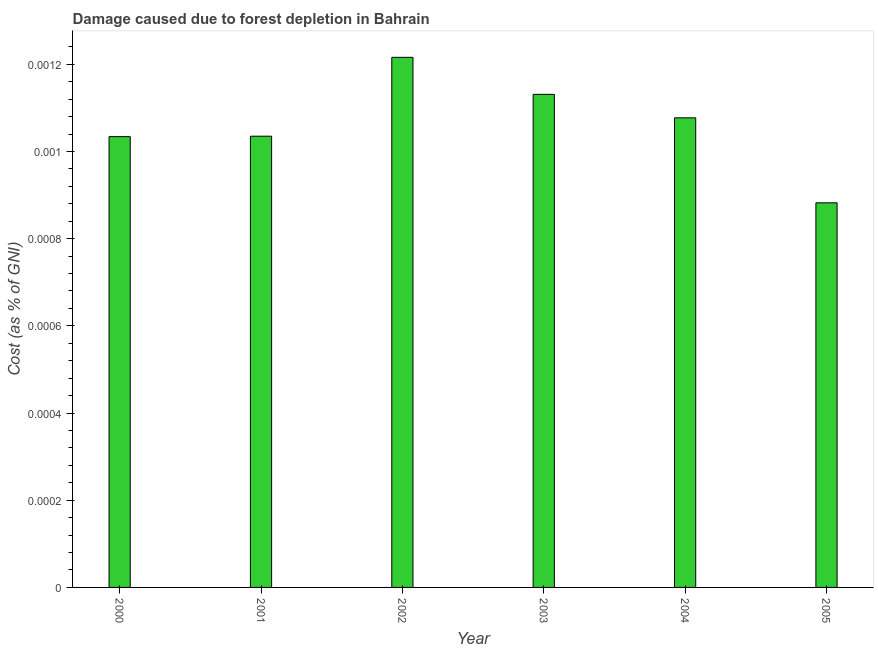Does the graph contain grids?
Your answer should be very brief. No. What is the title of the graph?
Offer a very short reply. Damage caused due to forest depletion in Bahrain. What is the label or title of the Y-axis?
Make the answer very short. Cost (as % of GNI). What is the damage caused due to forest depletion in 2004?
Your response must be concise. 0. Across all years, what is the maximum damage caused due to forest depletion?
Ensure brevity in your answer.  0. Across all years, what is the minimum damage caused due to forest depletion?
Give a very brief answer. 0. In which year was the damage caused due to forest depletion maximum?
Keep it short and to the point. 2002. In which year was the damage caused due to forest depletion minimum?
Keep it short and to the point. 2005. What is the sum of the damage caused due to forest depletion?
Make the answer very short. 0.01. What is the difference between the damage caused due to forest depletion in 2001 and 2002?
Provide a short and direct response. -0. What is the average damage caused due to forest depletion per year?
Provide a short and direct response. 0. What is the median damage caused due to forest depletion?
Make the answer very short. 0. In how many years, is the damage caused due to forest depletion greater than 0.00024 %?
Make the answer very short. 6. Do a majority of the years between 2003 and 2000 (inclusive) have damage caused due to forest depletion greater than 0.00092 %?
Make the answer very short. Yes. What is the ratio of the damage caused due to forest depletion in 2002 to that in 2005?
Your answer should be very brief. 1.38. Is the difference between the damage caused due to forest depletion in 2002 and 2005 greater than the difference between any two years?
Provide a succinct answer. Yes. Is the sum of the damage caused due to forest depletion in 2004 and 2005 greater than the maximum damage caused due to forest depletion across all years?
Offer a very short reply. Yes. How many years are there in the graph?
Your answer should be very brief. 6. What is the Cost (as % of GNI) of 2000?
Ensure brevity in your answer.  0. What is the Cost (as % of GNI) in 2001?
Ensure brevity in your answer.  0. What is the Cost (as % of GNI) of 2002?
Your answer should be very brief. 0. What is the Cost (as % of GNI) of 2003?
Keep it short and to the point. 0. What is the Cost (as % of GNI) in 2004?
Keep it short and to the point. 0. What is the Cost (as % of GNI) in 2005?
Your answer should be very brief. 0. What is the difference between the Cost (as % of GNI) in 2000 and 2002?
Make the answer very short. -0. What is the difference between the Cost (as % of GNI) in 2000 and 2003?
Ensure brevity in your answer.  -0. What is the difference between the Cost (as % of GNI) in 2000 and 2004?
Provide a short and direct response. -4e-5. What is the difference between the Cost (as % of GNI) in 2000 and 2005?
Offer a terse response. 0. What is the difference between the Cost (as % of GNI) in 2001 and 2002?
Make the answer very short. -0. What is the difference between the Cost (as % of GNI) in 2001 and 2003?
Your answer should be compact. -0. What is the difference between the Cost (as % of GNI) in 2001 and 2004?
Provide a succinct answer. -4e-5. What is the difference between the Cost (as % of GNI) in 2001 and 2005?
Offer a terse response. 0. What is the difference between the Cost (as % of GNI) in 2002 and 2003?
Your answer should be very brief. 8e-5. What is the difference between the Cost (as % of GNI) in 2002 and 2004?
Your answer should be very brief. 0. What is the difference between the Cost (as % of GNI) in 2002 and 2005?
Your response must be concise. 0. What is the difference between the Cost (as % of GNI) in 2003 and 2004?
Offer a very short reply. 5e-5. What is the difference between the Cost (as % of GNI) in 2003 and 2005?
Your answer should be compact. 0. What is the difference between the Cost (as % of GNI) in 2004 and 2005?
Your response must be concise. 0. What is the ratio of the Cost (as % of GNI) in 2000 to that in 2001?
Your response must be concise. 1. What is the ratio of the Cost (as % of GNI) in 2000 to that in 2003?
Offer a very short reply. 0.91. What is the ratio of the Cost (as % of GNI) in 2000 to that in 2004?
Provide a short and direct response. 0.96. What is the ratio of the Cost (as % of GNI) in 2000 to that in 2005?
Provide a succinct answer. 1.17. What is the ratio of the Cost (as % of GNI) in 2001 to that in 2002?
Your response must be concise. 0.85. What is the ratio of the Cost (as % of GNI) in 2001 to that in 2003?
Provide a short and direct response. 0.92. What is the ratio of the Cost (as % of GNI) in 2001 to that in 2005?
Offer a terse response. 1.17. What is the ratio of the Cost (as % of GNI) in 2002 to that in 2003?
Provide a short and direct response. 1.07. What is the ratio of the Cost (as % of GNI) in 2002 to that in 2004?
Ensure brevity in your answer.  1.13. What is the ratio of the Cost (as % of GNI) in 2002 to that in 2005?
Your answer should be compact. 1.38. What is the ratio of the Cost (as % of GNI) in 2003 to that in 2004?
Your response must be concise. 1.05. What is the ratio of the Cost (as % of GNI) in 2003 to that in 2005?
Ensure brevity in your answer.  1.28. What is the ratio of the Cost (as % of GNI) in 2004 to that in 2005?
Give a very brief answer. 1.22. 